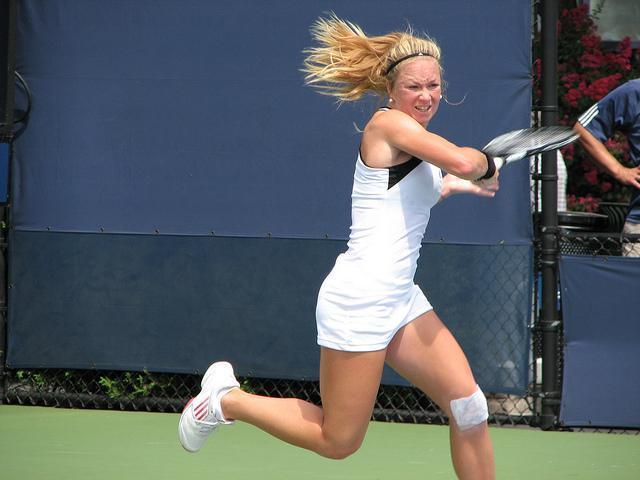How many people are there?
Give a very brief answer. 2. 